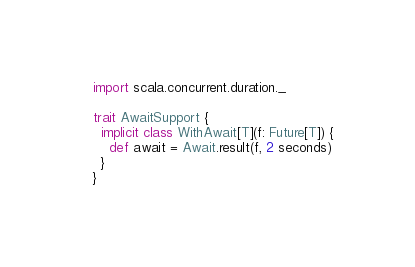<code> <loc_0><loc_0><loc_500><loc_500><_Scala_>import scala.concurrent.duration._

trait AwaitSupport {
  implicit class WithAwait[T](f: Future[T]) {
    def await = Await.result(f, 2 seconds)
  }
}
</code> 